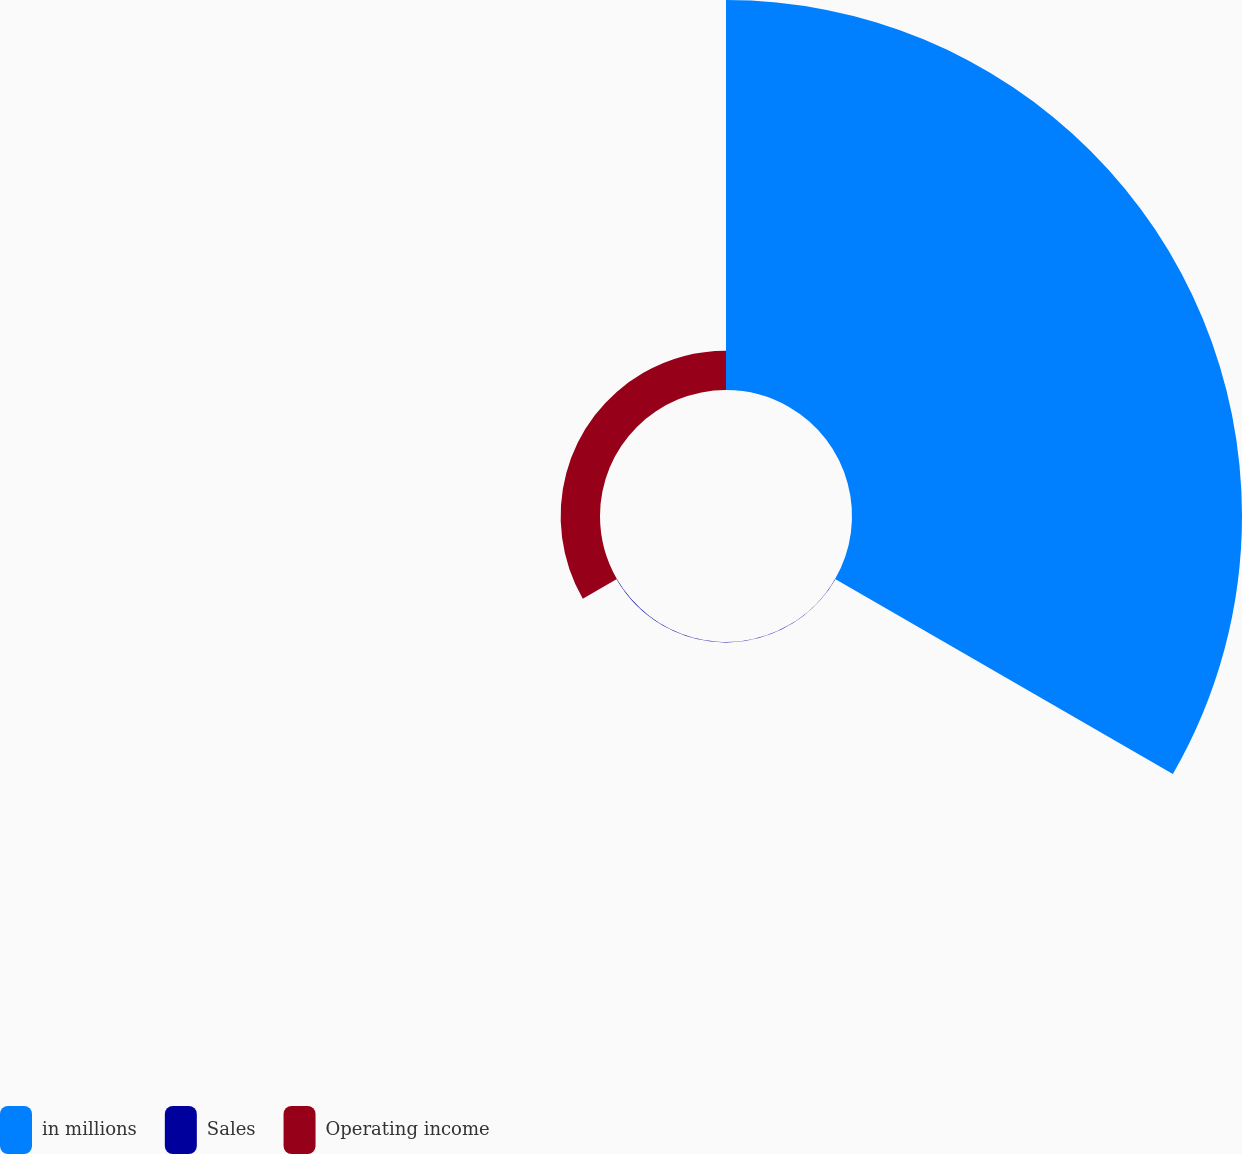Convert chart. <chart><loc_0><loc_0><loc_500><loc_500><pie_chart><fcel>in millions<fcel>Sales<fcel>Operating income<nl><fcel>90.75%<fcel>0.09%<fcel>9.16%<nl></chart> 